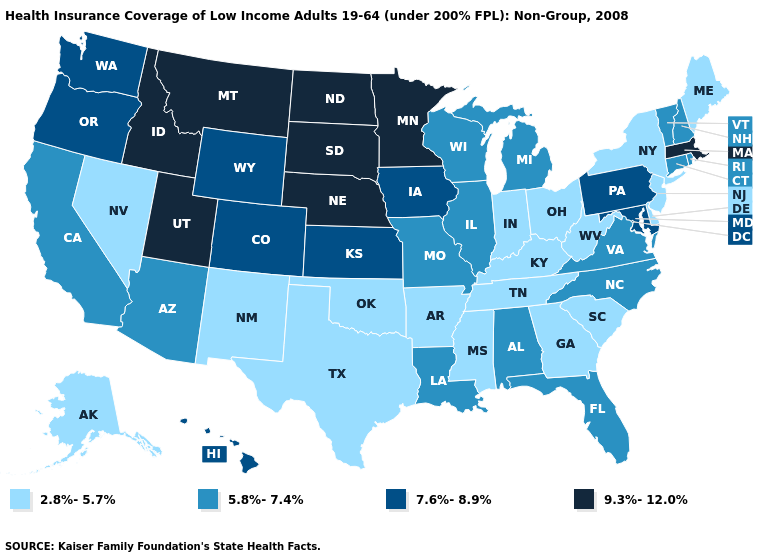What is the lowest value in states that border North Carolina?
Short answer required. 2.8%-5.7%. Name the states that have a value in the range 7.6%-8.9%?
Write a very short answer. Colorado, Hawaii, Iowa, Kansas, Maryland, Oregon, Pennsylvania, Washington, Wyoming. Does West Virginia have a lower value than Idaho?
Keep it brief. Yes. Which states hav the highest value in the West?
Quick response, please. Idaho, Montana, Utah. Does Washington have the highest value in the USA?
Concise answer only. No. What is the lowest value in the USA?
Concise answer only. 2.8%-5.7%. What is the value of Maryland?
Be succinct. 7.6%-8.9%. Among the states that border Florida , which have the highest value?
Short answer required. Alabama. What is the value of Utah?
Be succinct. 9.3%-12.0%. Does Florida have the lowest value in the South?
Write a very short answer. No. Among the states that border Florida , which have the lowest value?
Short answer required. Georgia. Which states hav the highest value in the South?
Give a very brief answer. Maryland. Is the legend a continuous bar?
Quick response, please. No. What is the value of Georgia?
Give a very brief answer. 2.8%-5.7%. 